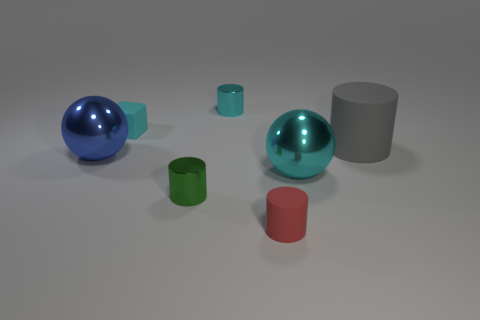There is a small rubber block; is its color the same as the large shiny object to the right of the matte cube?
Give a very brief answer. Yes. What number of other objects are there of the same color as the matte cube?
Offer a terse response. 2. Is there anything else that is the same size as the cyan matte object?
Offer a terse response. Yes. Are there more small red cylinders than large green spheres?
Offer a terse response. Yes. There is a rubber thing that is on the left side of the gray rubber cylinder and behind the tiny rubber cylinder; what is its size?
Offer a terse response. Small. What is the shape of the blue metallic object?
Give a very brief answer. Sphere. What number of red rubber objects have the same shape as the green object?
Provide a succinct answer. 1. Is the number of green cylinders that are in front of the tiny green metal cylinder less than the number of big cyan objects that are left of the blue sphere?
Provide a short and direct response. No. What number of gray objects are left of the tiny cylinder that is on the right side of the cyan metallic cylinder?
Offer a terse response. 0. Are there any small rubber cylinders?
Your response must be concise. Yes. 